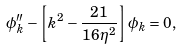Convert formula to latex. <formula><loc_0><loc_0><loc_500><loc_500>\phi _ { k } ^ { \prime \prime } - \left [ k ^ { 2 } - \frac { 2 1 } { 1 6 \, \eta ^ { 2 } } \right ] \phi _ { k } = 0 ,</formula> 